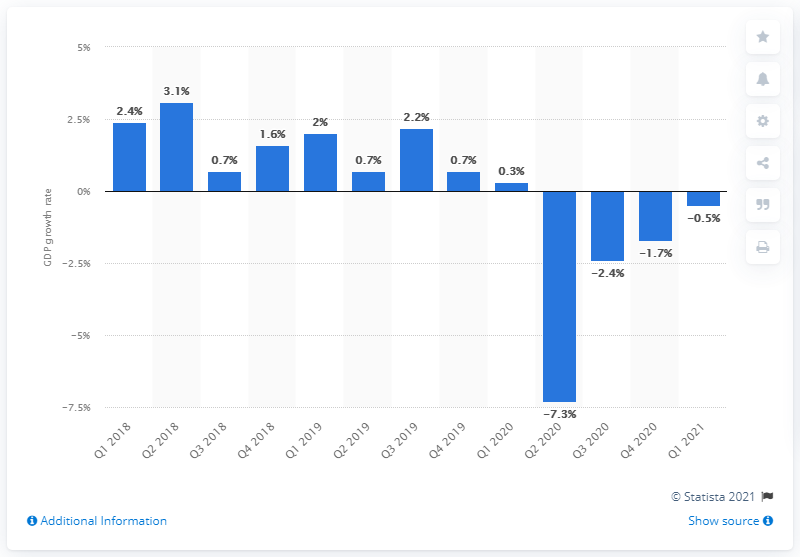Outline some significant characteristics in this image. According to the data, Sweden's Gross Domestic Product (GDP) growth in the second quarter of 2018 was 3.1%. 